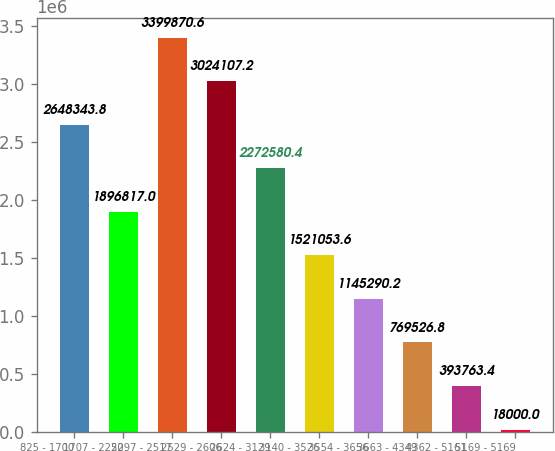<chart> <loc_0><loc_0><loc_500><loc_500><bar_chart><fcel>825 - 1700<fcel>1707 - 2250<fcel>2297 - 2517<fcel>2529 - 2606<fcel>2624 - 3129<fcel>3140 - 3526<fcel>3554 - 3656<fcel>3663 - 4349<fcel>4362 - 5161<fcel>5169 - 5169<nl><fcel>2.64834e+06<fcel>1.89682e+06<fcel>3.39987e+06<fcel>3.02411e+06<fcel>2.27258e+06<fcel>1.52105e+06<fcel>1.14529e+06<fcel>769527<fcel>393763<fcel>18000<nl></chart> 